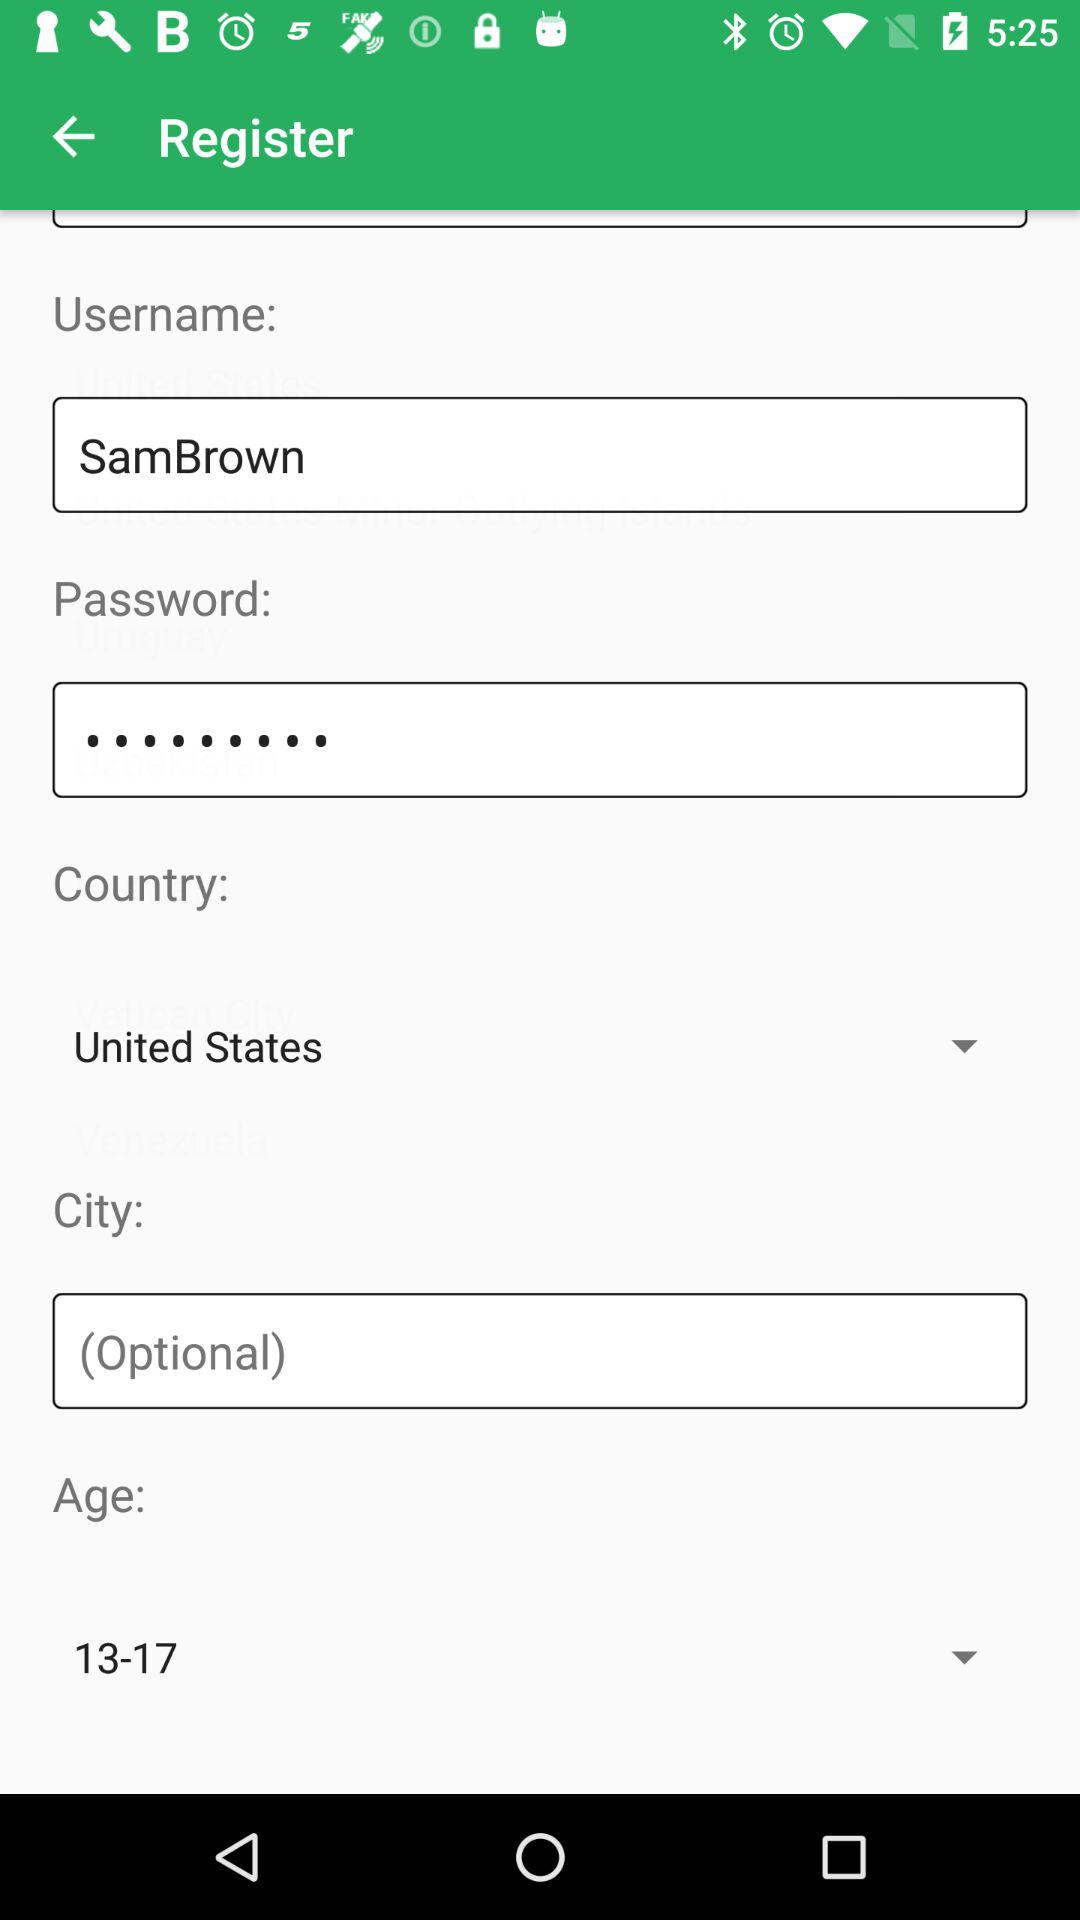Which country has been selected? The selected country is the United States. 